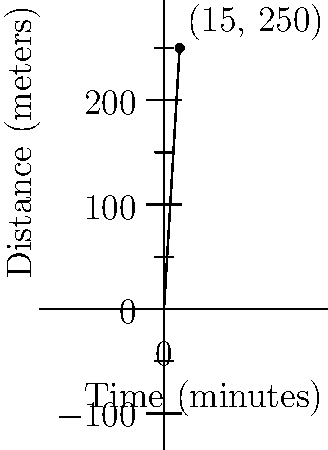During the championship match, your son sprinted from one end of the field to the other, covering a distance of 250 meters in 15 minutes. What was his average speed in meters per second? Let's break this down step-by-step:

1) First, we need to understand what average speed means:
   Average Speed = Total Distance / Total Time

2) We're given:
   - Distance = 250 meters
   - Time = 15 minutes

3) However, we need to convert minutes to seconds:
   15 minutes = 15 × 60 = 900 seconds

4) Now we can plug these values into our formula:
   Average Speed = 250 meters / 900 seconds

5) Let's do the division:
   Average Speed = $\frac{250}{900}$ = $\frac{25}{90}$ ≈ 0.2778 meters per second

6) We can round this to two decimal places for a more practical answer.

Therefore, your son's average speed was approximately 0.28 meters per second.
Answer: 0.28 m/s 